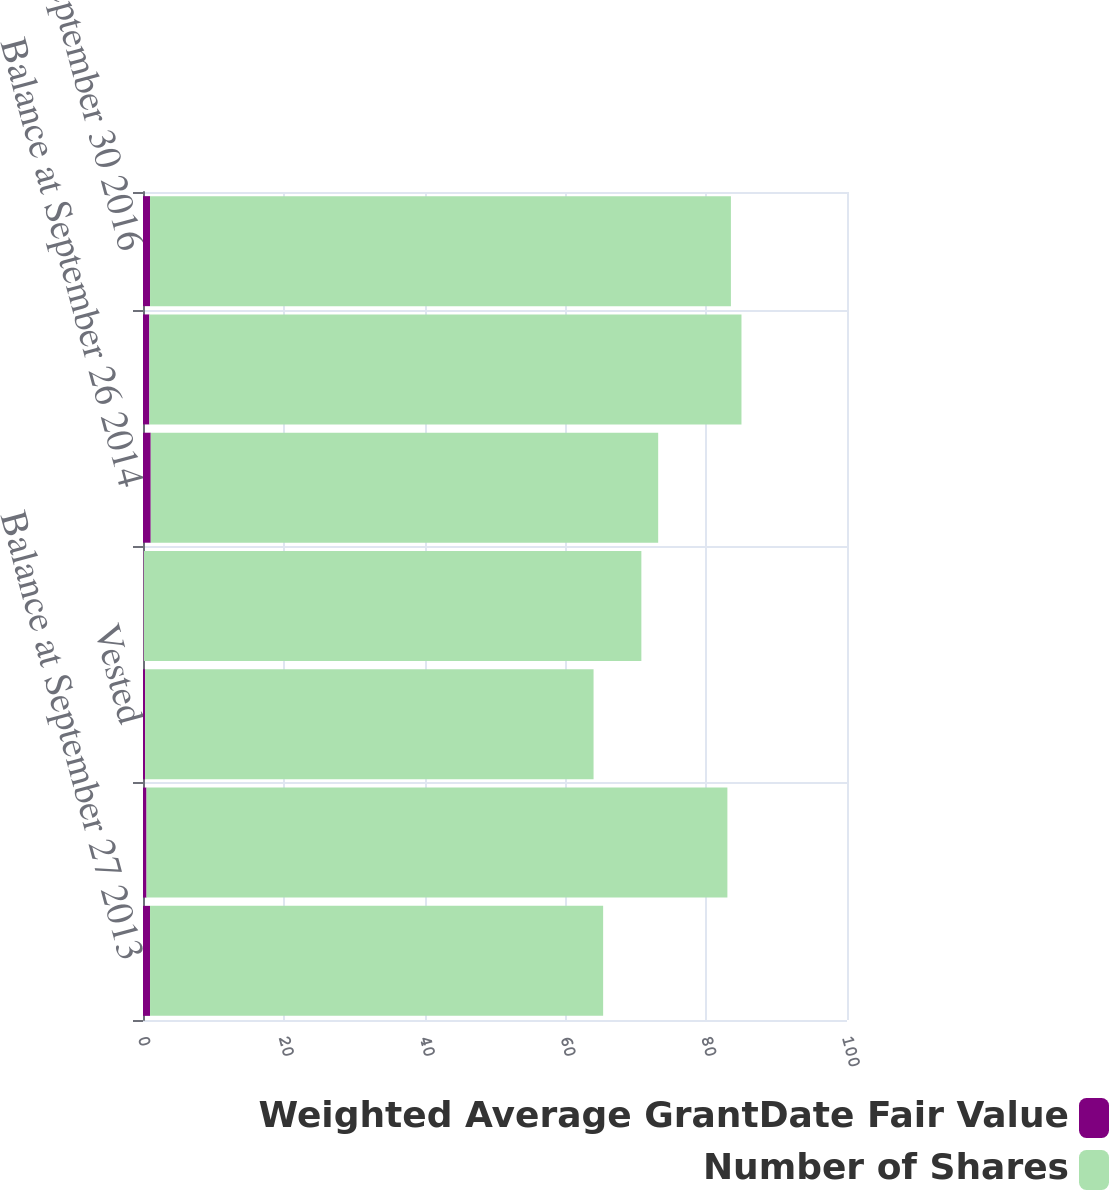Convert chart. <chart><loc_0><loc_0><loc_500><loc_500><stacked_bar_chart><ecel><fcel>Balance at September 27 2013<fcel>Granted<fcel>Vested<fcel>Canceled or expired<fcel>Balance at September 26 2014<fcel>Balance at October 2 2015<fcel>Balance at September 30 2016<nl><fcel>Weighted Average GrantDate Fair Value<fcel>1<fcel>0.5<fcel>0.3<fcel>0.1<fcel>1.1<fcel>0.9<fcel>1<nl><fcel>Number of Shares<fcel>64.36<fcel>82.51<fcel>63.7<fcel>70.69<fcel>72.08<fcel>84.11<fcel>82.51<nl></chart> 